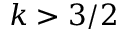Convert formula to latex. <formula><loc_0><loc_0><loc_500><loc_500>k > 3 / 2</formula> 